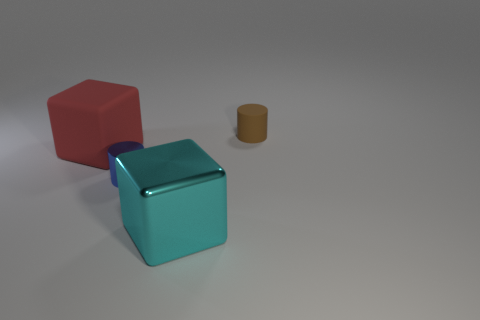What number of other things are there of the same size as the red block?
Your answer should be very brief. 1. What number of small brown rubber objects are there?
Give a very brief answer. 1. Do the red rubber object and the matte cylinder have the same size?
Ensure brevity in your answer.  No. How many other objects are the same shape as the big red object?
Make the answer very short. 1. There is a thing behind the large object that is on the left side of the blue metallic thing; what is it made of?
Provide a short and direct response. Rubber. There is a metal cylinder; are there any tiny metallic things right of it?
Offer a very short reply. No. There is a brown rubber cylinder; is it the same size as the metallic thing on the right side of the tiny metal cylinder?
Provide a short and direct response. No. There is a brown rubber thing that is the same shape as the small blue thing; what size is it?
Give a very brief answer. Small. Is there anything else that has the same material as the cyan block?
Your answer should be compact. Yes. There is a brown cylinder that is on the right side of the red block; is it the same size as the cylinder that is to the left of the tiny brown object?
Your answer should be compact. Yes. 